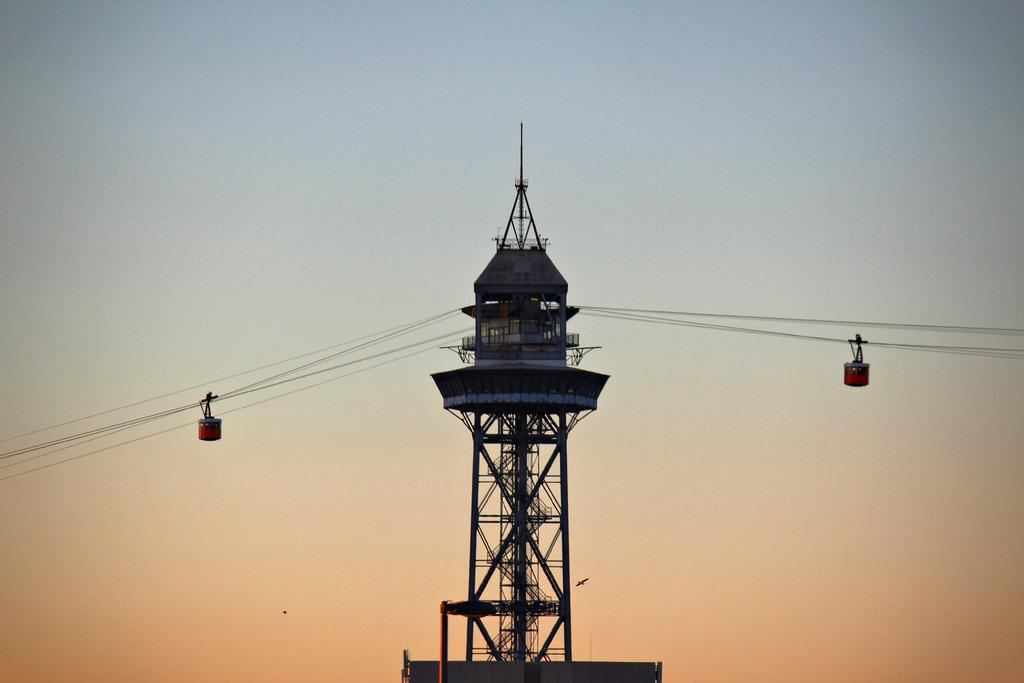What type of transportation is featured in the image? There are cable cars in the image. What connects the cable cars in the image? Cables are visible in the image. What structure is present in the image that supports the cable cars? There is a tower in the image. Can you see any pets participating in the party in the image? There is no party or pets present in the image; it features cable cars, cables, and a tower. 